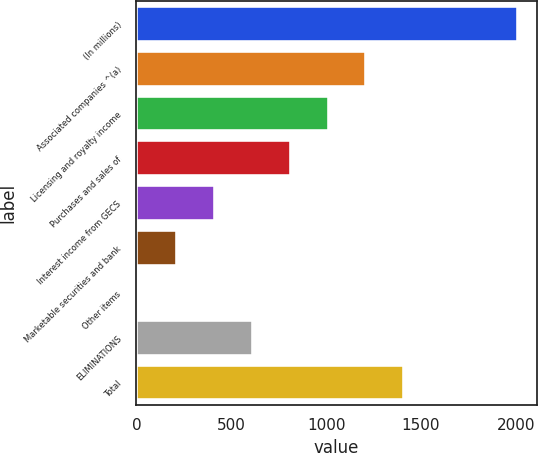<chart> <loc_0><loc_0><loc_500><loc_500><bar_chart><fcel>(In millions)<fcel>Associated companies ^(a)<fcel>Licensing and royalty income<fcel>Purchases and sales of<fcel>Interest income from GECS<fcel>Marketable securities and bank<fcel>Other items<fcel>ELIMINATIONS<fcel>Total<nl><fcel>2010<fcel>1212.4<fcel>1013<fcel>813.6<fcel>414.8<fcel>215.4<fcel>16<fcel>614.2<fcel>1411.8<nl></chart> 